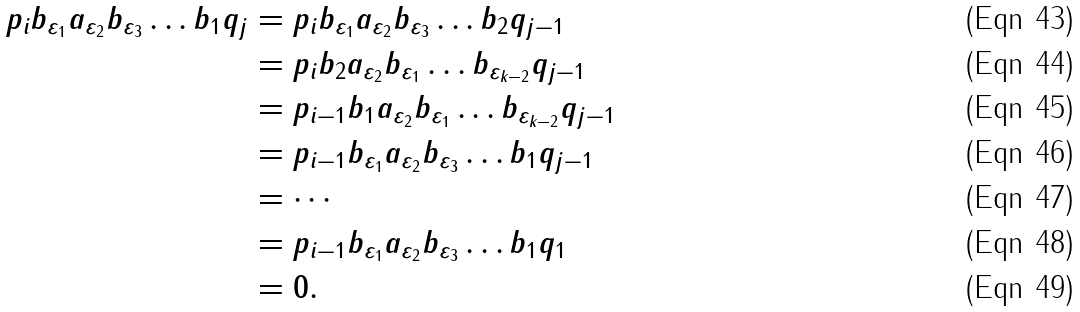<formula> <loc_0><loc_0><loc_500><loc_500>p _ { i } b _ { \varepsilon _ { 1 } } a _ { \varepsilon _ { 2 } } b _ { \varepsilon _ { 3 } } \dots b _ { 1 } q _ { j } & = p _ { i } b _ { \varepsilon _ { 1 } } a _ { \varepsilon _ { 2 } } b _ { \varepsilon _ { 3 } } \dots b _ { 2 } q _ { j - 1 } \\ & = p _ { i } b _ { 2 } a _ { \varepsilon _ { 2 } } b _ { \varepsilon _ { 1 } } \dots b _ { \varepsilon _ { k - 2 } } q _ { j - 1 } \\ & = p _ { i - 1 } b _ { 1 } a _ { \varepsilon _ { 2 } } b _ { \varepsilon _ { 1 } } \dots b _ { \varepsilon _ { k - 2 } } q _ { j - 1 } \\ & = p _ { i - 1 } b _ { \varepsilon _ { 1 } } a _ { \varepsilon _ { 2 } } b _ { \varepsilon _ { 3 } } \dots b _ { 1 } q _ { j - 1 } \\ & = \cdots \\ & = p _ { i - 1 } b _ { \varepsilon _ { 1 } } a _ { \varepsilon _ { 2 } } b _ { \varepsilon _ { 3 } } \dots b _ { 1 } q _ { 1 } \\ & = 0 .</formula> 